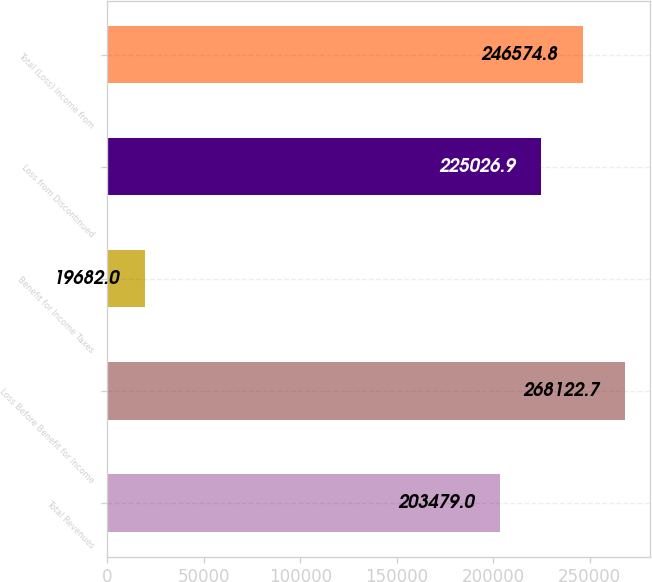Convert chart to OTSL. <chart><loc_0><loc_0><loc_500><loc_500><bar_chart><fcel>Total Revenues<fcel>Loss Before Benefit for Income<fcel>Benefit for Income Taxes<fcel>Loss from Discontinued<fcel>Total (Loss) Income from<nl><fcel>203479<fcel>268123<fcel>19682<fcel>225027<fcel>246575<nl></chart> 